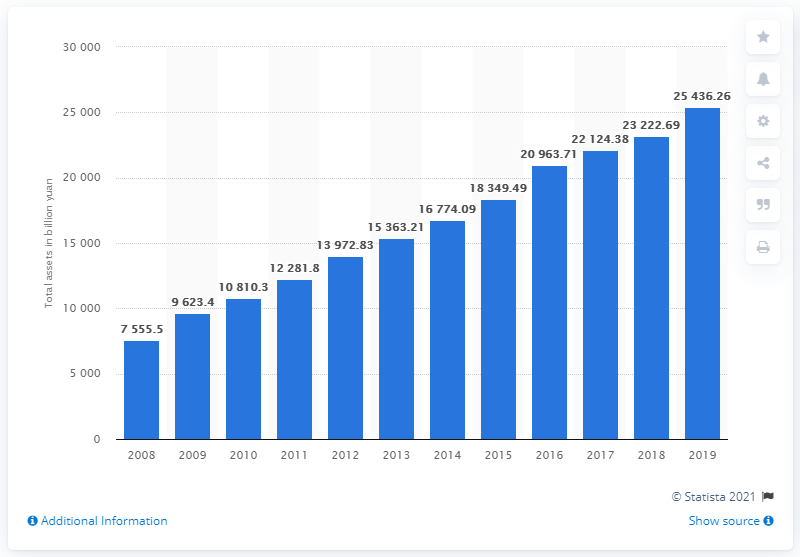Identify some key points in this picture. The total assets of China Construction Bank by the end of 2019 were worth 25,436.26. 